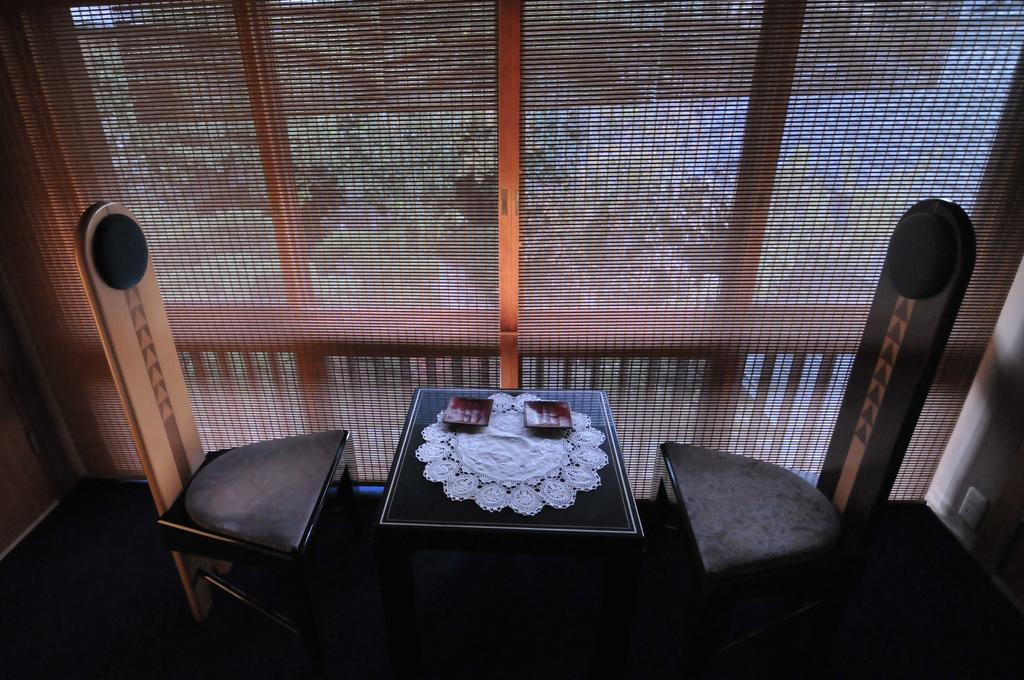What is located in the center of the image? There is a table in the center of the image. What can be seen on the right side of the image? There are chairs on the right side of the image. What is present on the left side of the image? There are chairs on the left side of the image. What is the purpose of the net in the image? The net in the center of the image suggests that it might be used for a game or activity. How many passengers are sitting on the chairs in the image? There are no passengers present in the image; it only shows chairs and a table. Can you tell me what type of frog is sitting on the table in the image? There is no frog present in the image; it only shows chairs, a table, and a net. 